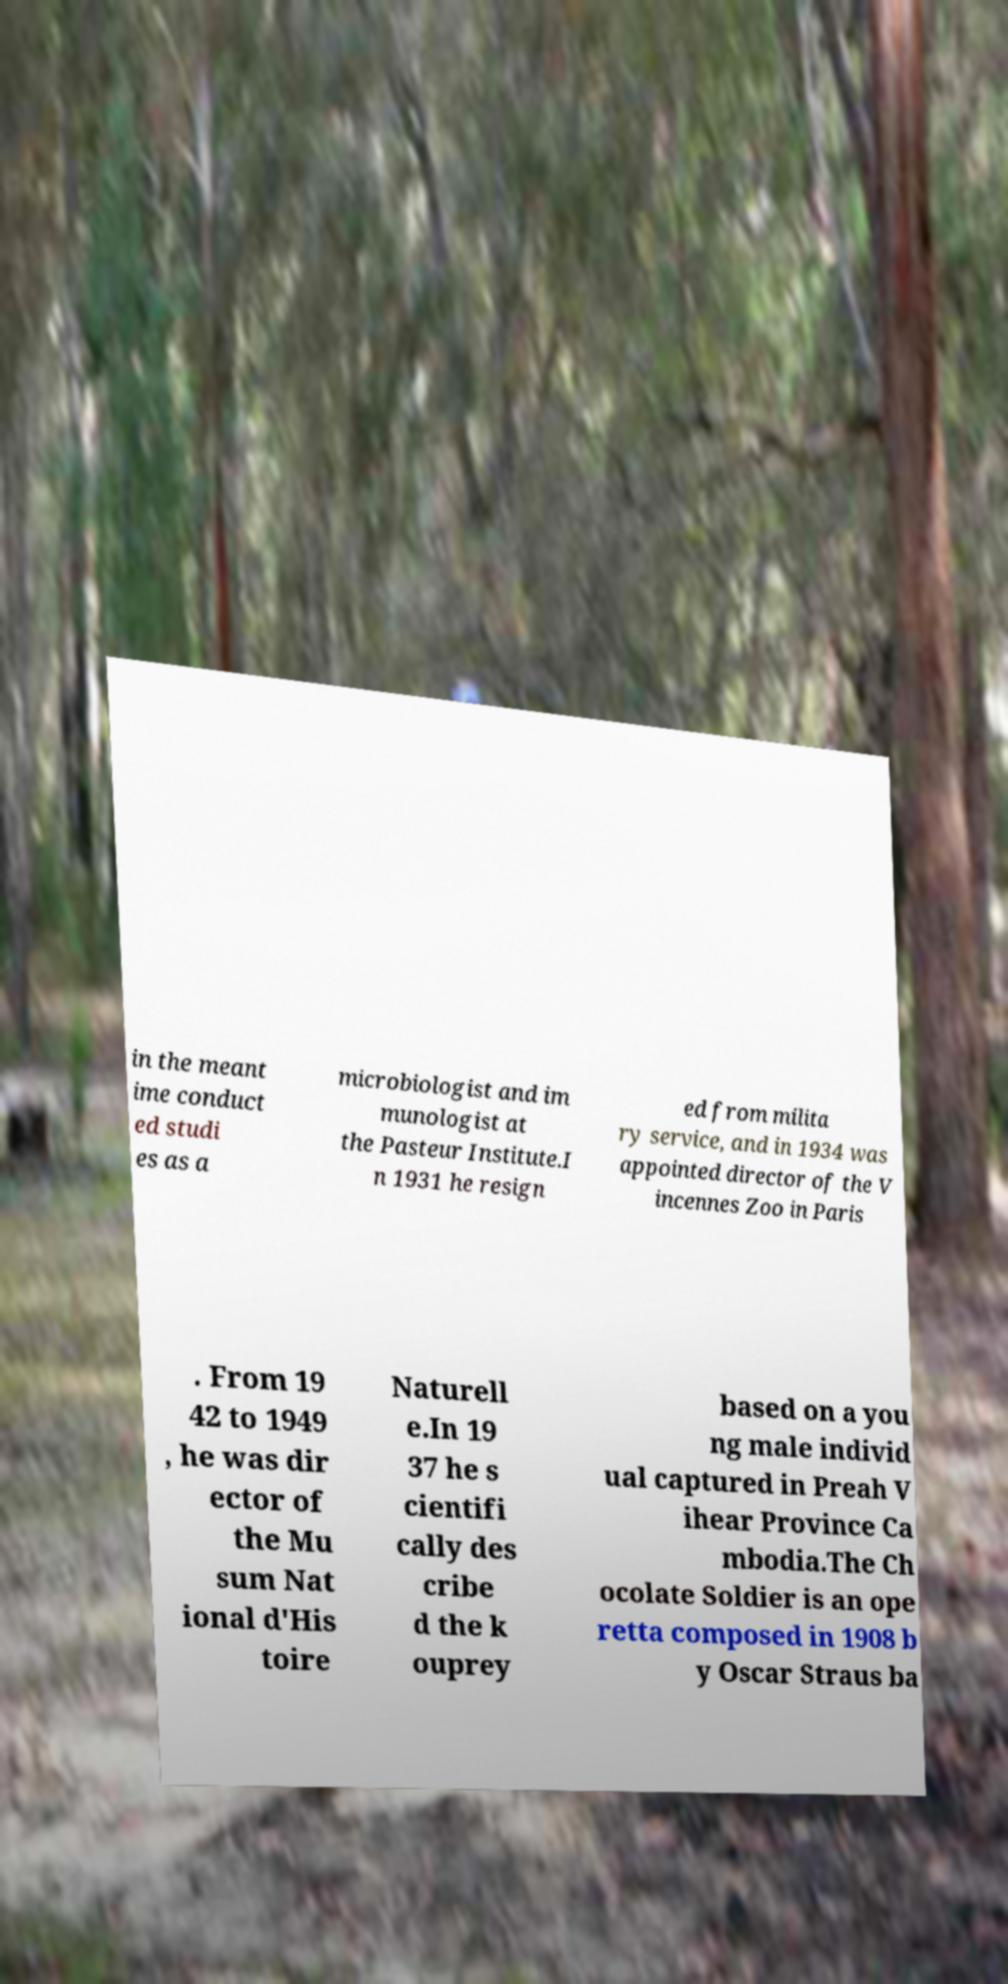For documentation purposes, I need the text within this image transcribed. Could you provide that? in the meant ime conduct ed studi es as a microbiologist and im munologist at the Pasteur Institute.I n 1931 he resign ed from milita ry service, and in 1934 was appointed director of the V incennes Zoo in Paris . From 19 42 to 1949 , he was dir ector of the Mu sum Nat ional d'His toire Naturell e.In 19 37 he s cientifi cally des cribe d the k ouprey based on a you ng male individ ual captured in Preah V ihear Province Ca mbodia.The Ch ocolate Soldier is an ope retta composed in 1908 b y Oscar Straus ba 